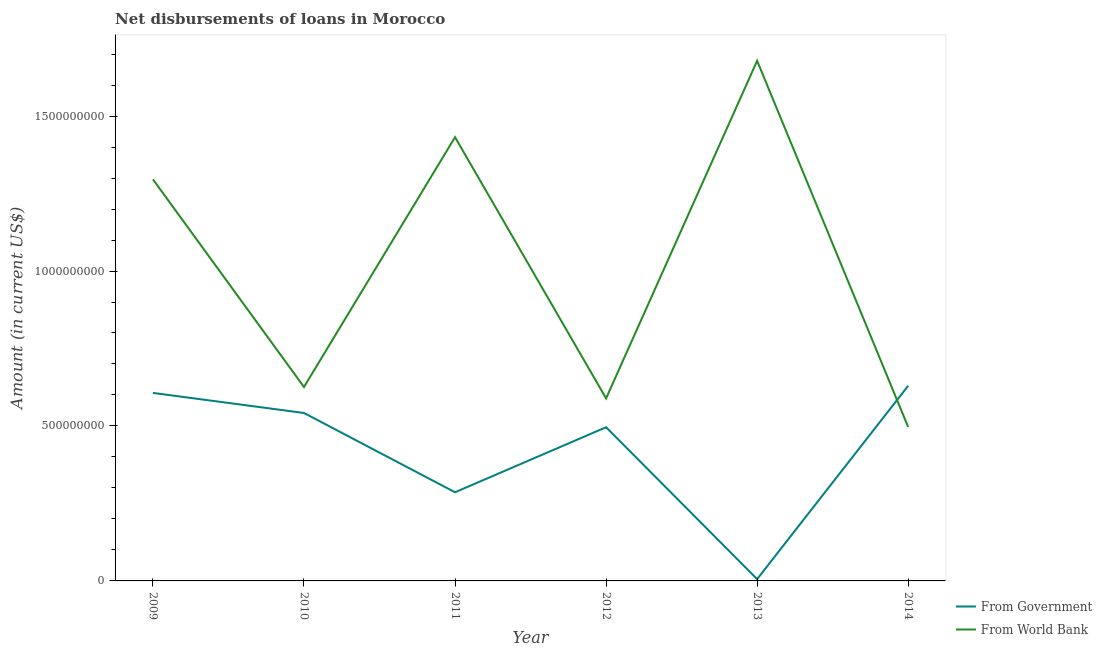Does the line corresponding to net disbursements of loan from government intersect with the line corresponding to net disbursements of loan from world bank?
Make the answer very short. Yes. Is the number of lines equal to the number of legend labels?
Provide a short and direct response. Yes. What is the net disbursements of loan from world bank in 2014?
Provide a succinct answer. 4.97e+08. Across all years, what is the maximum net disbursements of loan from world bank?
Offer a terse response. 1.68e+09. Across all years, what is the minimum net disbursements of loan from government?
Your answer should be very brief. 5.81e+06. What is the total net disbursements of loan from government in the graph?
Your answer should be compact. 2.57e+09. What is the difference between the net disbursements of loan from government in 2010 and that in 2013?
Give a very brief answer. 5.36e+08. What is the difference between the net disbursements of loan from world bank in 2011 and the net disbursements of loan from government in 2013?
Your answer should be compact. 1.43e+09. What is the average net disbursements of loan from world bank per year?
Provide a succinct answer. 1.02e+09. In the year 2014, what is the difference between the net disbursements of loan from government and net disbursements of loan from world bank?
Offer a terse response. 1.33e+08. In how many years, is the net disbursements of loan from government greater than 100000000 US$?
Keep it short and to the point. 5. What is the ratio of the net disbursements of loan from government in 2010 to that in 2014?
Keep it short and to the point. 0.86. Is the net disbursements of loan from world bank in 2009 less than that in 2010?
Make the answer very short. No. What is the difference between the highest and the second highest net disbursements of loan from government?
Ensure brevity in your answer.  2.29e+07. What is the difference between the highest and the lowest net disbursements of loan from world bank?
Your answer should be very brief. 1.18e+09. In how many years, is the net disbursements of loan from government greater than the average net disbursements of loan from government taken over all years?
Give a very brief answer. 4. Is the net disbursements of loan from world bank strictly greater than the net disbursements of loan from government over the years?
Offer a very short reply. No. How many lines are there?
Give a very brief answer. 2. What is the difference between two consecutive major ticks on the Y-axis?
Offer a terse response. 5.00e+08. Does the graph contain any zero values?
Offer a very short reply. No. What is the title of the graph?
Ensure brevity in your answer.  Net disbursements of loans in Morocco. What is the label or title of the X-axis?
Your response must be concise. Year. What is the label or title of the Y-axis?
Your answer should be compact. Amount (in current US$). What is the Amount (in current US$) of From Government in 2009?
Make the answer very short. 6.07e+08. What is the Amount (in current US$) of From World Bank in 2009?
Your response must be concise. 1.30e+09. What is the Amount (in current US$) of From Government in 2010?
Keep it short and to the point. 5.42e+08. What is the Amount (in current US$) of From World Bank in 2010?
Your answer should be compact. 6.26e+08. What is the Amount (in current US$) of From Government in 2011?
Your answer should be compact. 2.86e+08. What is the Amount (in current US$) in From World Bank in 2011?
Offer a very short reply. 1.43e+09. What is the Amount (in current US$) of From Government in 2012?
Your answer should be compact. 4.96e+08. What is the Amount (in current US$) of From World Bank in 2012?
Offer a very short reply. 5.89e+08. What is the Amount (in current US$) in From Government in 2013?
Keep it short and to the point. 5.81e+06. What is the Amount (in current US$) of From World Bank in 2013?
Provide a short and direct response. 1.68e+09. What is the Amount (in current US$) of From Government in 2014?
Your response must be concise. 6.30e+08. What is the Amount (in current US$) in From World Bank in 2014?
Your response must be concise. 4.97e+08. Across all years, what is the maximum Amount (in current US$) in From Government?
Offer a terse response. 6.30e+08. Across all years, what is the maximum Amount (in current US$) of From World Bank?
Your response must be concise. 1.68e+09. Across all years, what is the minimum Amount (in current US$) of From Government?
Your response must be concise. 5.81e+06. Across all years, what is the minimum Amount (in current US$) of From World Bank?
Offer a terse response. 4.97e+08. What is the total Amount (in current US$) of From Government in the graph?
Your answer should be compact. 2.57e+09. What is the total Amount (in current US$) in From World Bank in the graph?
Offer a very short reply. 6.12e+09. What is the difference between the Amount (in current US$) in From Government in 2009 and that in 2010?
Make the answer very short. 6.47e+07. What is the difference between the Amount (in current US$) of From World Bank in 2009 and that in 2010?
Offer a very short reply. 6.70e+08. What is the difference between the Amount (in current US$) in From Government in 2009 and that in 2011?
Keep it short and to the point. 3.21e+08. What is the difference between the Amount (in current US$) in From World Bank in 2009 and that in 2011?
Your answer should be compact. -1.36e+08. What is the difference between the Amount (in current US$) in From Government in 2009 and that in 2012?
Offer a very short reply. 1.11e+08. What is the difference between the Amount (in current US$) in From World Bank in 2009 and that in 2012?
Give a very brief answer. 7.07e+08. What is the difference between the Amount (in current US$) of From Government in 2009 and that in 2013?
Offer a very short reply. 6.01e+08. What is the difference between the Amount (in current US$) of From World Bank in 2009 and that in 2013?
Provide a succinct answer. -3.83e+08. What is the difference between the Amount (in current US$) of From Government in 2009 and that in 2014?
Ensure brevity in your answer.  -2.29e+07. What is the difference between the Amount (in current US$) of From World Bank in 2009 and that in 2014?
Provide a short and direct response. 7.99e+08. What is the difference between the Amount (in current US$) of From Government in 2010 and that in 2011?
Make the answer very short. 2.56e+08. What is the difference between the Amount (in current US$) in From World Bank in 2010 and that in 2011?
Your answer should be very brief. -8.06e+08. What is the difference between the Amount (in current US$) in From Government in 2010 and that in 2012?
Ensure brevity in your answer.  4.60e+07. What is the difference between the Amount (in current US$) of From World Bank in 2010 and that in 2012?
Ensure brevity in your answer.  3.67e+07. What is the difference between the Amount (in current US$) of From Government in 2010 and that in 2013?
Offer a very short reply. 5.36e+08. What is the difference between the Amount (in current US$) of From World Bank in 2010 and that in 2013?
Ensure brevity in your answer.  -1.05e+09. What is the difference between the Amount (in current US$) of From Government in 2010 and that in 2014?
Make the answer very short. -8.76e+07. What is the difference between the Amount (in current US$) in From World Bank in 2010 and that in 2014?
Give a very brief answer. 1.29e+08. What is the difference between the Amount (in current US$) in From Government in 2011 and that in 2012?
Your response must be concise. -2.10e+08. What is the difference between the Amount (in current US$) of From World Bank in 2011 and that in 2012?
Ensure brevity in your answer.  8.43e+08. What is the difference between the Amount (in current US$) in From Government in 2011 and that in 2013?
Offer a terse response. 2.80e+08. What is the difference between the Amount (in current US$) of From World Bank in 2011 and that in 2013?
Make the answer very short. -2.47e+08. What is the difference between the Amount (in current US$) in From Government in 2011 and that in 2014?
Keep it short and to the point. -3.43e+08. What is the difference between the Amount (in current US$) in From World Bank in 2011 and that in 2014?
Offer a terse response. 9.35e+08. What is the difference between the Amount (in current US$) in From Government in 2012 and that in 2013?
Offer a very short reply. 4.90e+08. What is the difference between the Amount (in current US$) of From World Bank in 2012 and that in 2013?
Provide a short and direct response. -1.09e+09. What is the difference between the Amount (in current US$) in From Government in 2012 and that in 2014?
Offer a very short reply. -1.34e+08. What is the difference between the Amount (in current US$) in From World Bank in 2012 and that in 2014?
Keep it short and to the point. 9.25e+07. What is the difference between the Amount (in current US$) of From Government in 2013 and that in 2014?
Ensure brevity in your answer.  -6.24e+08. What is the difference between the Amount (in current US$) of From World Bank in 2013 and that in 2014?
Your answer should be compact. 1.18e+09. What is the difference between the Amount (in current US$) in From Government in 2009 and the Amount (in current US$) in From World Bank in 2010?
Your answer should be very brief. -1.91e+07. What is the difference between the Amount (in current US$) of From Government in 2009 and the Amount (in current US$) of From World Bank in 2011?
Offer a very short reply. -8.25e+08. What is the difference between the Amount (in current US$) of From Government in 2009 and the Amount (in current US$) of From World Bank in 2012?
Provide a short and direct response. 1.76e+07. What is the difference between the Amount (in current US$) in From Government in 2009 and the Amount (in current US$) in From World Bank in 2013?
Your answer should be compact. -1.07e+09. What is the difference between the Amount (in current US$) of From Government in 2009 and the Amount (in current US$) of From World Bank in 2014?
Provide a short and direct response. 1.10e+08. What is the difference between the Amount (in current US$) of From Government in 2010 and the Amount (in current US$) of From World Bank in 2011?
Offer a very short reply. -8.90e+08. What is the difference between the Amount (in current US$) of From Government in 2010 and the Amount (in current US$) of From World Bank in 2012?
Ensure brevity in your answer.  -4.71e+07. What is the difference between the Amount (in current US$) in From Government in 2010 and the Amount (in current US$) in From World Bank in 2013?
Provide a succinct answer. -1.14e+09. What is the difference between the Amount (in current US$) in From Government in 2010 and the Amount (in current US$) in From World Bank in 2014?
Ensure brevity in your answer.  4.54e+07. What is the difference between the Amount (in current US$) of From Government in 2011 and the Amount (in current US$) of From World Bank in 2012?
Your response must be concise. -3.03e+08. What is the difference between the Amount (in current US$) of From Government in 2011 and the Amount (in current US$) of From World Bank in 2013?
Offer a terse response. -1.39e+09. What is the difference between the Amount (in current US$) of From Government in 2011 and the Amount (in current US$) of From World Bank in 2014?
Provide a succinct answer. -2.10e+08. What is the difference between the Amount (in current US$) in From Government in 2012 and the Amount (in current US$) in From World Bank in 2013?
Give a very brief answer. -1.18e+09. What is the difference between the Amount (in current US$) in From Government in 2012 and the Amount (in current US$) in From World Bank in 2014?
Offer a terse response. -6.80e+05. What is the difference between the Amount (in current US$) of From Government in 2013 and the Amount (in current US$) of From World Bank in 2014?
Ensure brevity in your answer.  -4.91e+08. What is the average Amount (in current US$) of From Government per year?
Keep it short and to the point. 4.28e+08. What is the average Amount (in current US$) in From World Bank per year?
Your answer should be very brief. 1.02e+09. In the year 2009, what is the difference between the Amount (in current US$) of From Government and Amount (in current US$) of From World Bank?
Provide a short and direct response. -6.89e+08. In the year 2010, what is the difference between the Amount (in current US$) of From Government and Amount (in current US$) of From World Bank?
Provide a succinct answer. -8.38e+07. In the year 2011, what is the difference between the Amount (in current US$) of From Government and Amount (in current US$) of From World Bank?
Your response must be concise. -1.15e+09. In the year 2012, what is the difference between the Amount (in current US$) in From Government and Amount (in current US$) in From World Bank?
Provide a short and direct response. -9.31e+07. In the year 2013, what is the difference between the Amount (in current US$) in From Government and Amount (in current US$) in From World Bank?
Offer a terse response. -1.67e+09. In the year 2014, what is the difference between the Amount (in current US$) of From Government and Amount (in current US$) of From World Bank?
Keep it short and to the point. 1.33e+08. What is the ratio of the Amount (in current US$) in From Government in 2009 to that in 2010?
Keep it short and to the point. 1.12. What is the ratio of the Amount (in current US$) in From World Bank in 2009 to that in 2010?
Keep it short and to the point. 2.07. What is the ratio of the Amount (in current US$) in From Government in 2009 to that in 2011?
Give a very brief answer. 2.12. What is the ratio of the Amount (in current US$) of From World Bank in 2009 to that in 2011?
Make the answer very short. 0.91. What is the ratio of the Amount (in current US$) in From Government in 2009 to that in 2012?
Offer a terse response. 1.22. What is the ratio of the Amount (in current US$) of From World Bank in 2009 to that in 2012?
Your answer should be compact. 2.2. What is the ratio of the Amount (in current US$) in From Government in 2009 to that in 2013?
Your response must be concise. 104.38. What is the ratio of the Amount (in current US$) in From World Bank in 2009 to that in 2013?
Ensure brevity in your answer.  0.77. What is the ratio of the Amount (in current US$) in From Government in 2009 to that in 2014?
Offer a very short reply. 0.96. What is the ratio of the Amount (in current US$) of From World Bank in 2009 to that in 2014?
Offer a very short reply. 2.61. What is the ratio of the Amount (in current US$) of From Government in 2010 to that in 2011?
Provide a short and direct response. 1.89. What is the ratio of the Amount (in current US$) of From World Bank in 2010 to that in 2011?
Give a very brief answer. 0.44. What is the ratio of the Amount (in current US$) in From Government in 2010 to that in 2012?
Ensure brevity in your answer.  1.09. What is the ratio of the Amount (in current US$) in From World Bank in 2010 to that in 2012?
Offer a terse response. 1.06. What is the ratio of the Amount (in current US$) of From Government in 2010 to that in 2013?
Offer a terse response. 93.24. What is the ratio of the Amount (in current US$) of From World Bank in 2010 to that in 2013?
Keep it short and to the point. 0.37. What is the ratio of the Amount (in current US$) of From Government in 2010 to that in 2014?
Give a very brief answer. 0.86. What is the ratio of the Amount (in current US$) of From World Bank in 2010 to that in 2014?
Give a very brief answer. 1.26. What is the ratio of the Amount (in current US$) of From Government in 2011 to that in 2012?
Ensure brevity in your answer.  0.58. What is the ratio of the Amount (in current US$) in From World Bank in 2011 to that in 2012?
Provide a succinct answer. 2.43. What is the ratio of the Amount (in current US$) in From Government in 2011 to that in 2013?
Your answer should be very brief. 49.22. What is the ratio of the Amount (in current US$) in From World Bank in 2011 to that in 2013?
Give a very brief answer. 0.85. What is the ratio of the Amount (in current US$) in From Government in 2011 to that in 2014?
Offer a very short reply. 0.45. What is the ratio of the Amount (in current US$) in From World Bank in 2011 to that in 2014?
Make the answer very short. 2.88. What is the ratio of the Amount (in current US$) of From Government in 2012 to that in 2013?
Provide a succinct answer. 85.32. What is the ratio of the Amount (in current US$) of From World Bank in 2012 to that in 2013?
Offer a terse response. 0.35. What is the ratio of the Amount (in current US$) of From Government in 2012 to that in 2014?
Offer a very short reply. 0.79. What is the ratio of the Amount (in current US$) in From World Bank in 2012 to that in 2014?
Offer a terse response. 1.19. What is the ratio of the Amount (in current US$) in From Government in 2013 to that in 2014?
Your answer should be very brief. 0.01. What is the ratio of the Amount (in current US$) in From World Bank in 2013 to that in 2014?
Provide a succinct answer. 3.38. What is the difference between the highest and the second highest Amount (in current US$) of From Government?
Offer a very short reply. 2.29e+07. What is the difference between the highest and the second highest Amount (in current US$) in From World Bank?
Give a very brief answer. 2.47e+08. What is the difference between the highest and the lowest Amount (in current US$) in From Government?
Give a very brief answer. 6.24e+08. What is the difference between the highest and the lowest Amount (in current US$) of From World Bank?
Give a very brief answer. 1.18e+09. 